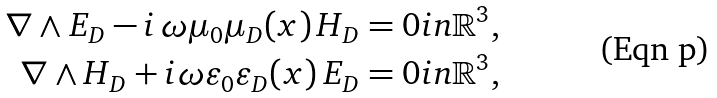Convert formula to latex. <formula><loc_0><loc_0><loc_500><loc_500>\nabla \wedge E _ { D } - i \, \omega \mu _ { 0 } \mu _ { D } ( x ) \, H _ { D } & = 0 i n \mathbb { R } ^ { 3 } , \\ \nabla \wedge H _ { D } + i \omega \varepsilon _ { 0 } \varepsilon _ { D } ( x ) \, E _ { D } & = 0 i n \mathbb { R } ^ { 3 } ,</formula> 